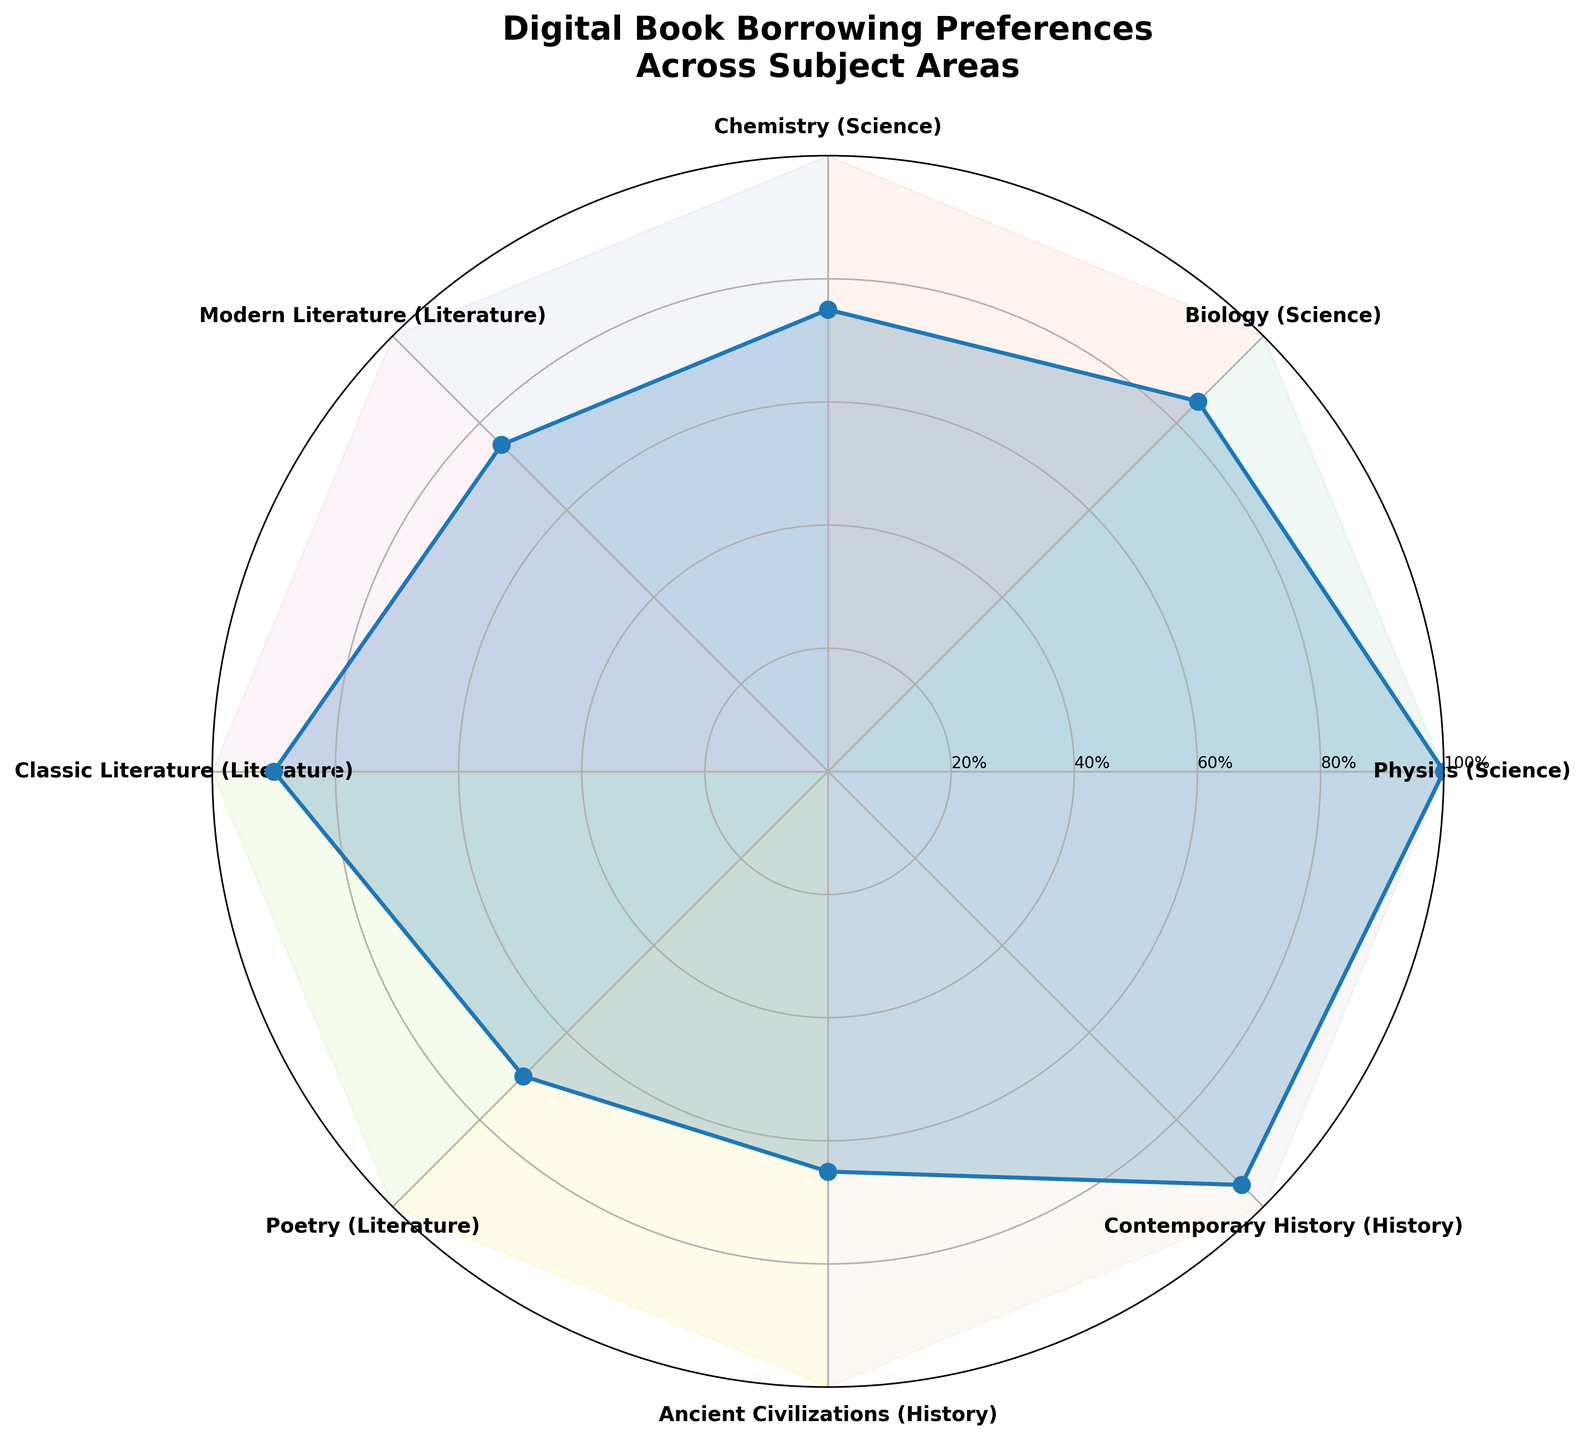What is the title of the figure? The title of the figure is the text displayed at the top, which helps identify the main subject of the chart. Here, the title is "Digital Book Borrowing Preferences Across Subject Areas".
Answer: Digital Book Borrowing Preferences Across Subject Areas How many subject areas are displayed in the chart? The chart displays each subject area around the circle, and by counting these labels, we can determine the number of subject areas shown.
Answer: 8 What is the value for "Contemporary History" in December? To find this, look at the radial line extending to "Contemporary History" and check the value it reaches on the radar chart. Here it reaches the outermost circle indicating 95.
Answer: 95 Which subject area has the highest borrowing in December? The subject with the highest value in the outer circle of December is located at the extremity of the largest radius. Observing, we can see "Physics (Science)" has the highest value, reaching 100.
Answer: Physics (Science) Is the borrowing preference for "Poetry (Literature)" higher than "Modern Literature (Literature)" in December? For December, compare the radial heights for both "Poetry (Literature)" and "Modern Literature (Literature)". "Poetry (Literature)" has a value at 70, while "Modern Literature (Literature)" is at 75, making the latter higher.
Answer: No What is the total borrowing value for "Science" subjects in December? Sum the values of all "Science" related subjects which are Physics: 100, Biology: 85, and Chemistry: 75. Adding these up gives 100 + 85 + 75 = 260.
Answer: 260 Which subject area shows a borrowing value of 55 in December? Check for which radial line intersects with the circle representing the 55 value. "Ancient Civilizations (History)" hits the 55 mark.
Answer: Ancient Civilizations (History) What is the average borrowing for all subject areas in December? Add up the values for all subject areas: 100 + 85 + 75 + 75 + 90 + 70 + 65 + 95. Then divide by the number of subjects, which is 8. The sum is 655 and the average is 655 / 8 = 81.875.
Answer: 81.875 Which subject area has the least amount of borrowing in December? Find the subject area on the figure that extends to the lowest radial value. "Poetry (Literature)" reaches the innermost circle at a value of 70, the minimum borrowing.
Answer: Poetry (Literature) How does borrowing in "Biology (Science)" compare to "Classic Literature (Literature)" in December? Compare the radial extensions for these subjects. "Biology (Science)" reaches 85 while "Classic Literature (Literature)" extends to 90, making the latter higher.
Answer: Lower 